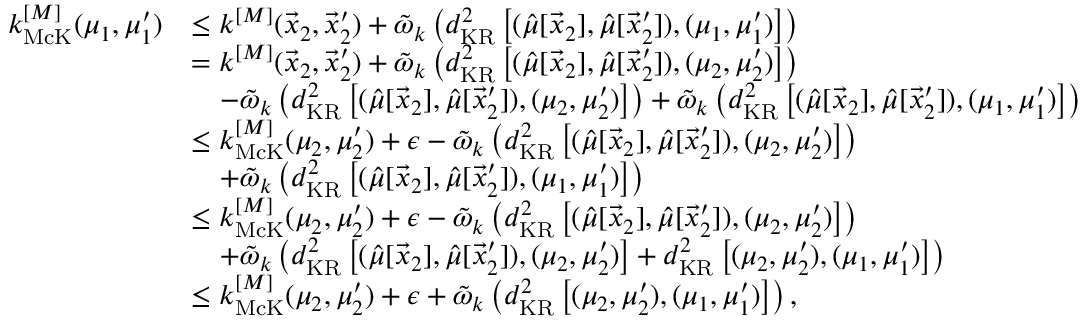<formula> <loc_0><loc_0><loc_500><loc_500>\begin{array} { r l } { k _ { M c K } ^ { [ M ] } ( \mu _ { 1 } , \mu _ { 1 } ^ { \prime } ) } & { \leq k ^ { [ M ] } ( \vec { x } _ { 2 } , \vec { x } _ { 2 } ^ { \prime } ) + \tilde { \omega } _ { k } \left ( d _ { K R } ^ { 2 } \left [ ( \hat { \mu } [ \vec { x } _ { 2 } ] , \hat { \mu } [ \vec { x } _ { 2 } ^ { \prime } ] ) , ( \mu _ { 1 } , \mu _ { 1 } ^ { \prime } ) \right ] \right ) } \\ & { = k ^ { [ M ] } ( \vec { x } _ { 2 } , \vec { x } _ { 2 } ^ { \prime } ) + \tilde { \omega } _ { k } \left ( d _ { K R } ^ { 2 } \left [ ( \hat { \mu } [ \vec { x } _ { 2 } ] , \hat { \mu } [ \vec { x } _ { 2 } ^ { \prime } ] ) , ( \mu _ { 2 } , \mu _ { 2 } ^ { \prime } ) \right ] \right ) } \\ & { \quad - \tilde { \omega } _ { k } \left ( d _ { K R } ^ { 2 } \left [ ( \hat { \mu } [ \vec { x } _ { 2 } ] , \hat { \mu } [ \vec { x } _ { 2 } ^ { \prime } ] ) , ( \mu _ { 2 } , \mu _ { 2 } ^ { \prime } ) \right ] \right ) + \tilde { \omega } _ { k } \left ( d _ { K R } ^ { 2 } \left [ ( \hat { \mu } [ \vec { x } _ { 2 } ] , \hat { \mu } [ \vec { x } _ { 2 } ^ { \prime } ] ) , ( \mu _ { 1 } , \mu _ { 1 } ^ { \prime } ) \right ] \right ) } \\ & { \leq k _ { M c K } ^ { [ M ] } ( \mu _ { 2 } , \mu _ { 2 } ^ { \prime } ) + \epsilon - \tilde { \omega } _ { k } \left ( d _ { K R } ^ { 2 } \left [ ( \hat { \mu } [ \vec { x } _ { 2 } ] , \hat { \mu } [ \vec { x } _ { 2 } ^ { \prime } ] ) , ( \mu _ { 2 } , \mu _ { 2 } ^ { \prime } ) \right ] \right ) } \\ & { \quad + \tilde { \omega } _ { k } \left ( d _ { K R } ^ { 2 } \left [ ( \hat { \mu } [ \vec { x } _ { 2 } ] , \hat { \mu } [ \vec { x } _ { 2 } ^ { \prime } ] ) , ( \mu _ { 1 } , \mu _ { 1 } ^ { \prime } ) \right ] \right ) } \\ & { \leq k _ { M c K } ^ { [ M ] } ( \mu _ { 2 } , \mu _ { 2 } ^ { \prime } ) + \epsilon - \tilde { \omega } _ { k } \left ( d _ { K R } ^ { 2 } \left [ ( \hat { \mu } [ \vec { x } _ { 2 } ] , \hat { \mu } [ \vec { x } _ { 2 } ^ { \prime } ] ) , ( \mu _ { 2 } , \mu _ { 2 } ^ { \prime } ) \right ] \right ) } \\ & { \quad + \tilde { \omega } _ { k } \left ( d _ { K R } ^ { 2 } \left [ ( \hat { \mu } [ \vec { x } _ { 2 } ] , \hat { \mu } [ \vec { x } _ { 2 } ^ { \prime } ] ) , ( \mu _ { 2 } , \mu _ { 2 } ^ { \prime } ) \right ] + d _ { K R } ^ { 2 } \left [ ( \mu _ { 2 } , \mu _ { 2 } ^ { \prime } ) , ( \mu _ { 1 } , \mu _ { 1 } ^ { \prime } ) \right ] \right ) } \\ & { \leq k _ { M c K } ^ { [ M ] } ( \mu _ { 2 } , \mu _ { 2 } ^ { \prime } ) + \epsilon + \tilde { \omega } _ { k } \left ( d _ { K R } ^ { 2 } \left [ ( \mu _ { 2 } , \mu _ { 2 } ^ { \prime } ) , ( \mu _ { 1 } , \mu _ { 1 } ^ { \prime } ) \right ] \right ) , } \end{array}</formula> 